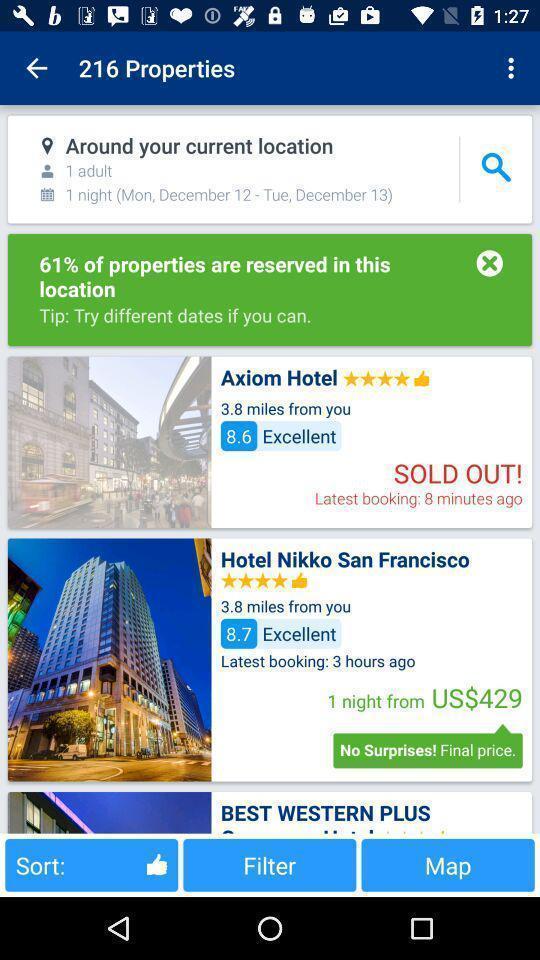Summarize the information in this screenshot. Page displaying properties in the app. 